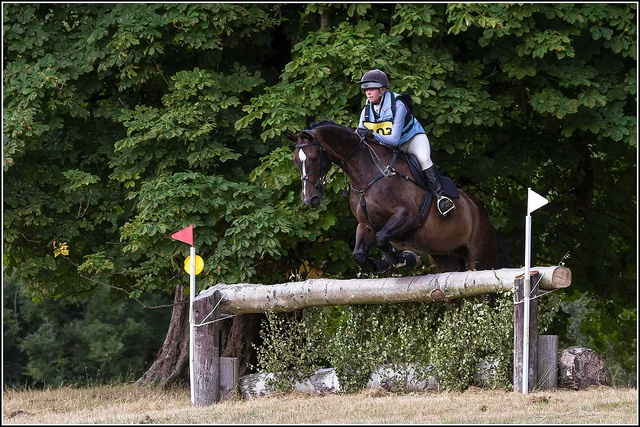Describe the objects in this image and their specific colors. I can see horse in black and gray tones and people in black, lavender, darkgray, and gray tones in this image. 